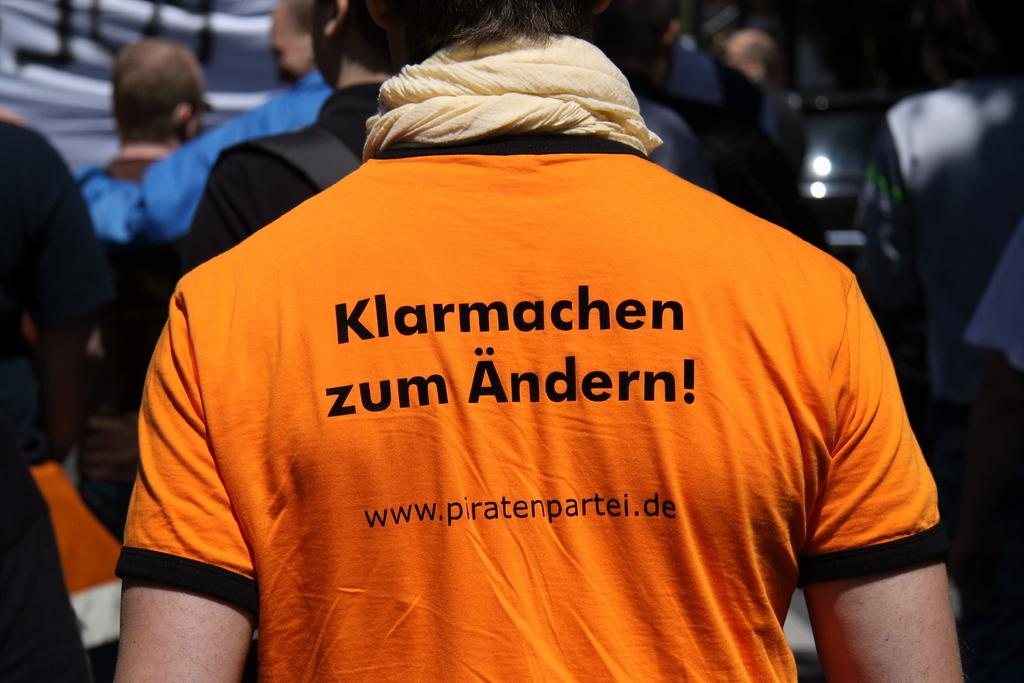<image>
Describe the image concisely. A man standing with his back facing the camera  wearing a orange tee shirt with german words emblazoned on the back. 